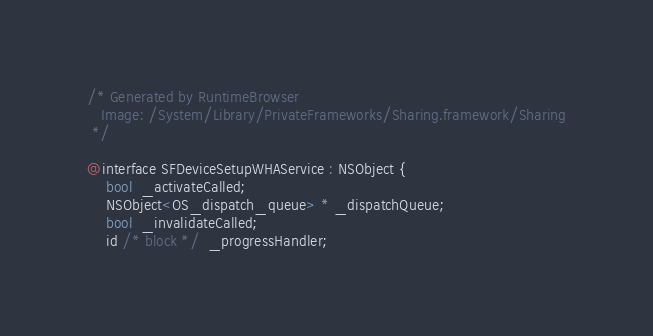<code> <loc_0><loc_0><loc_500><loc_500><_C_>/* Generated by RuntimeBrowser
   Image: /System/Library/PrivateFrameworks/Sharing.framework/Sharing
 */

@interface SFDeviceSetupWHAService : NSObject {
    bool  _activateCalled;
    NSObject<OS_dispatch_queue> * _dispatchQueue;
    bool  _invalidateCalled;
    id /* block */  _progressHandler;</code> 